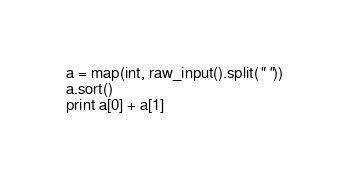<code> <loc_0><loc_0><loc_500><loc_500><_Python_>a = map(int, raw_input().split(" "))
a.sort()
print a[0] + a[1]</code> 